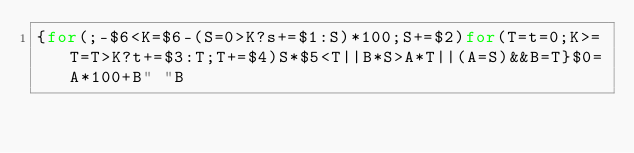Convert code to text. <code><loc_0><loc_0><loc_500><loc_500><_Awk_>{for(;-$6<K=$6-(S=0>K?s+=$1:S)*100;S+=$2)for(T=t=0;K>=T=T>K?t+=$3:T;T+=$4)S*$5<T||B*S>A*T||(A=S)&&B=T}$0=A*100+B" "B</code> 